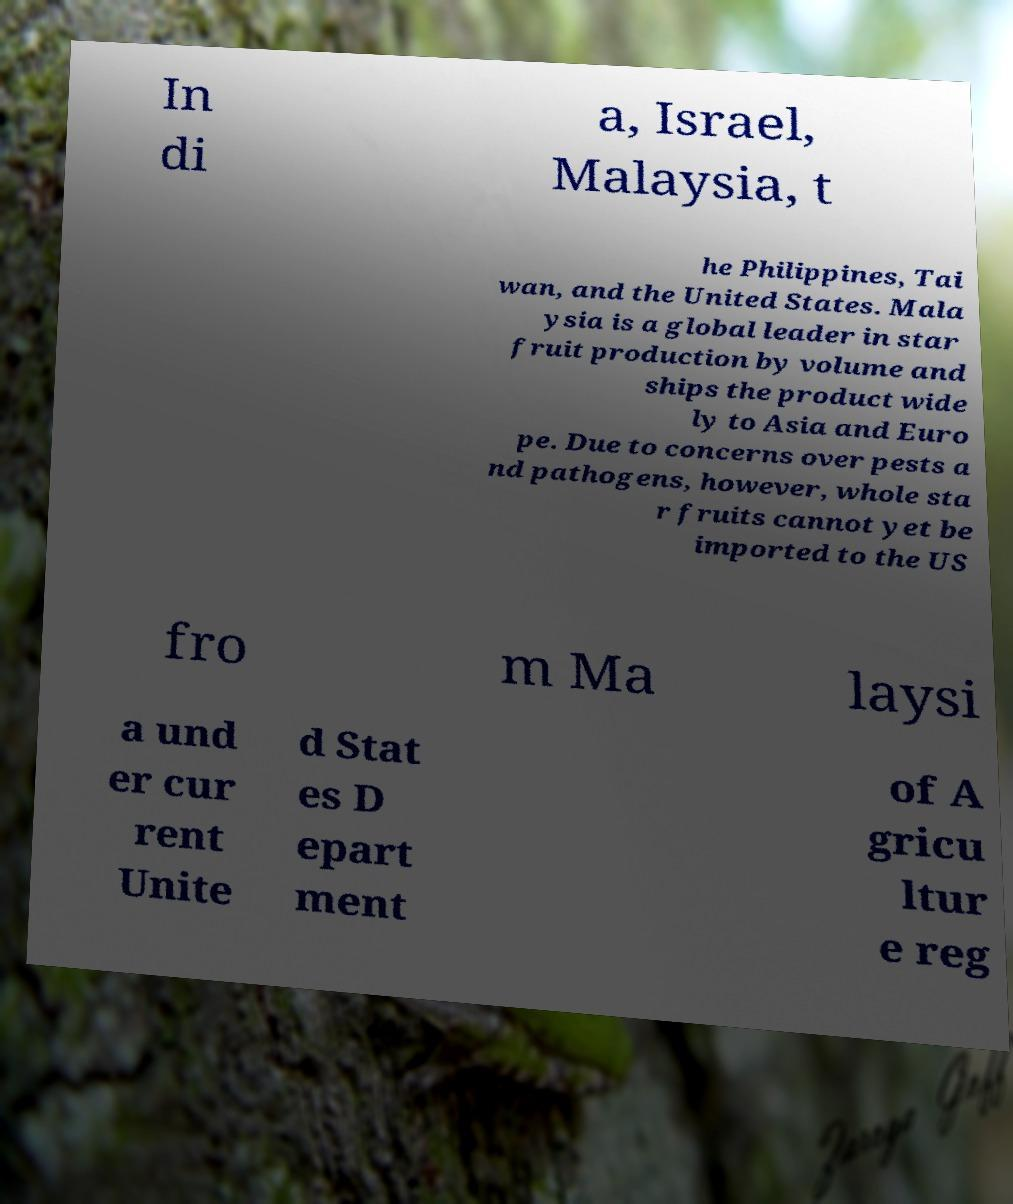I need the written content from this picture converted into text. Can you do that? In di a, Israel, Malaysia, t he Philippines, Tai wan, and the United States. Mala ysia is a global leader in star fruit production by volume and ships the product wide ly to Asia and Euro pe. Due to concerns over pests a nd pathogens, however, whole sta r fruits cannot yet be imported to the US fro m Ma laysi a und er cur rent Unite d Stat es D epart ment of A gricu ltur e reg 